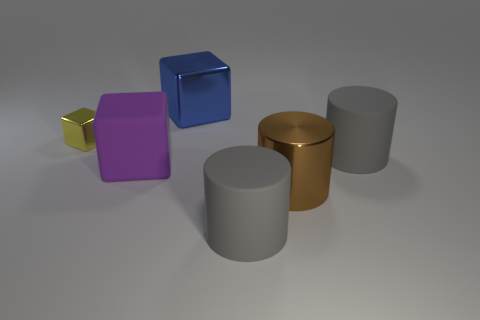Which objects have reflective surfaces? Each object in the image has a reflective surface, giving off subtle reflections and highlights from the environment around them. 